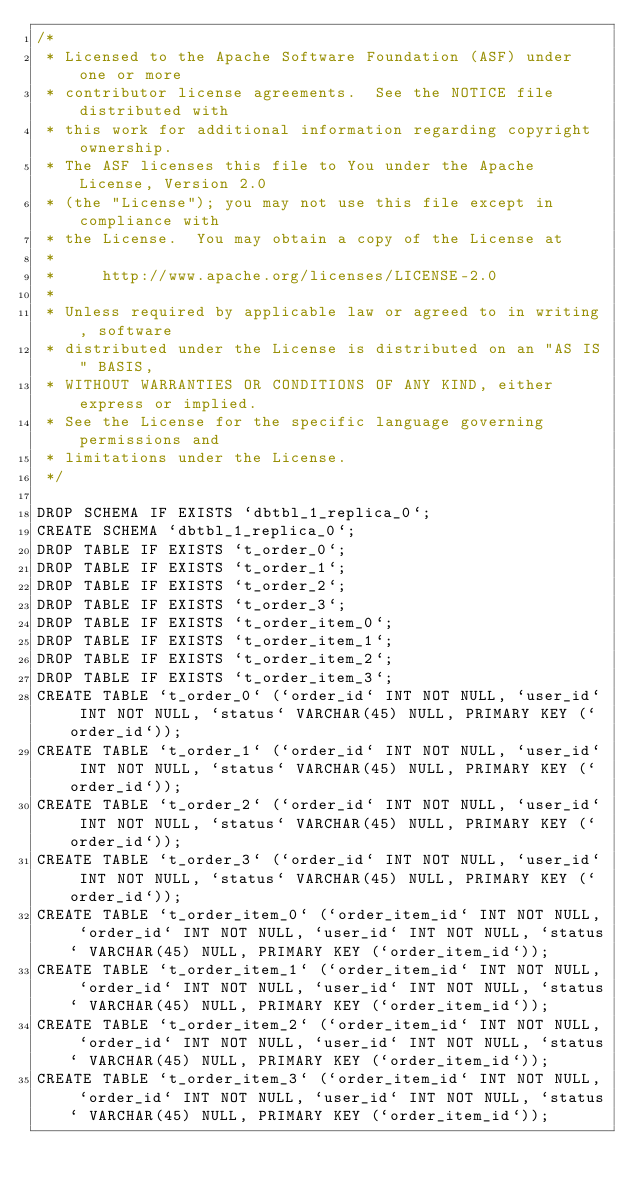<code> <loc_0><loc_0><loc_500><loc_500><_SQL_>/*
 * Licensed to the Apache Software Foundation (ASF) under one or more
 * contributor license agreements.  See the NOTICE file distributed with
 * this work for additional information regarding copyright ownership.
 * The ASF licenses this file to You under the Apache License, Version 2.0
 * (the "License"); you may not use this file except in compliance with
 * the License.  You may obtain a copy of the License at
 *
 *     http://www.apache.org/licenses/LICENSE-2.0
 *
 * Unless required by applicable law or agreed to in writing, software
 * distributed under the License is distributed on an "AS IS" BASIS,
 * WITHOUT WARRANTIES OR CONDITIONS OF ANY KIND, either express or implied.
 * See the License for the specific language governing permissions and
 * limitations under the License.
 */

DROP SCHEMA IF EXISTS `dbtbl_1_replica_0`;
CREATE SCHEMA `dbtbl_1_replica_0`;
DROP TABLE IF EXISTS `t_order_0`;
DROP TABLE IF EXISTS `t_order_1`;
DROP TABLE IF EXISTS `t_order_2`;
DROP TABLE IF EXISTS `t_order_3`;
DROP TABLE IF EXISTS `t_order_item_0`;
DROP TABLE IF EXISTS `t_order_item_1`;
DROP TABLE IF EXISTS `t_order_item_2`;
DROP TABLE IF EXISTS `t_order_item_3`;
CREATE TABLE `t_order_0` (`order_id` INT NOT NULL, `user_id` INT NOT NULL, `status` VARCHAR(45) NULL, PRIMARY KEY (`order_id`));
CREATE TABLE `t_order_1` (`order_id` INT NOT NULL, `user_id` INT NOT NULL, `status` VARCHAR(45) NULL, PRIMARY KEY (`order_id`));
CREATE TABLE `t_order_2` (`order_id` INT NOT NULL, `user_id` INT NOT NULL, `status` VARCHAR(45) NULL, PRIMARY KEY (`order_id`));
CREATE TABLE `t_order_3` (`order_id` INT NOT NULL, `user_id` INT NOT NULL, `status` VARCHAR(45) NULL, PRIMARY KEY (`order_id`));
CREATE TABLE `t_order_item_0` (`order_item_id` INT NOT NULL, `order_id` INT NOT NULL, `user_id` INT NOT NULL, `status` VARCHAR(45) NULL, PRIMARY KEY (`order_item_id`));
CREATE TABLE `t_order_item_1` (`order_item_id` INT NOT NULL, `order_id` INT NOT NULL, `user_id` INT NOT NULL, `status` VARCHAR(45) NULL, PRIMARY KEY (`order_item_id`));
CREATE TABLE `t_order_item_2` (`order_item_id` INT NOT NULL, `order_id` INT NOT NULL, `user_id` INT NOT NULL, `status` VARCHAR(45) NULL, PRIMARY KEY (`order_item_id`));
CREATE TABLE `t_order_item_3` (`order_item_id` INT NOT NULL, `order_id` INT NOT NULL, `user_id` INT NOT NULL, `status` VARCHAR(45) NULL, PRIMARY KEY (`order_item_id`));
</code> 